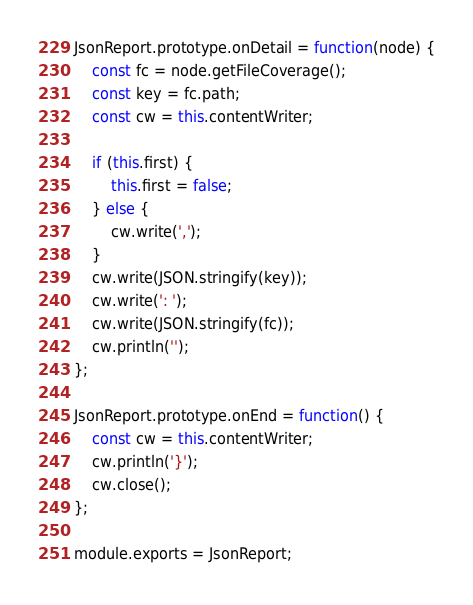Convert code to text. <code><loc_0><loc_0><loc_500><loc_500><_JavaScript_>JsonReport.prototype.onDetail = function(node) {
    const fc = node.getFileCoverage();
    const key = fc.path;
    const cw = this.contentWriter;

    if (this.first) {
        this.first = false;
    } else {
        cw.write(',');
    }
    cw.write(JSON.stringify(key));
    cw.write(': ');
    cw.write(JSON.stringify(fc));
    cw.println('');
};

JsonReport.prototype.onEnd = function() {
    const cw = this.contentWriter;
    cw.println('}');
    cw.close();
};

module.exports = JsonReport;
</code> 